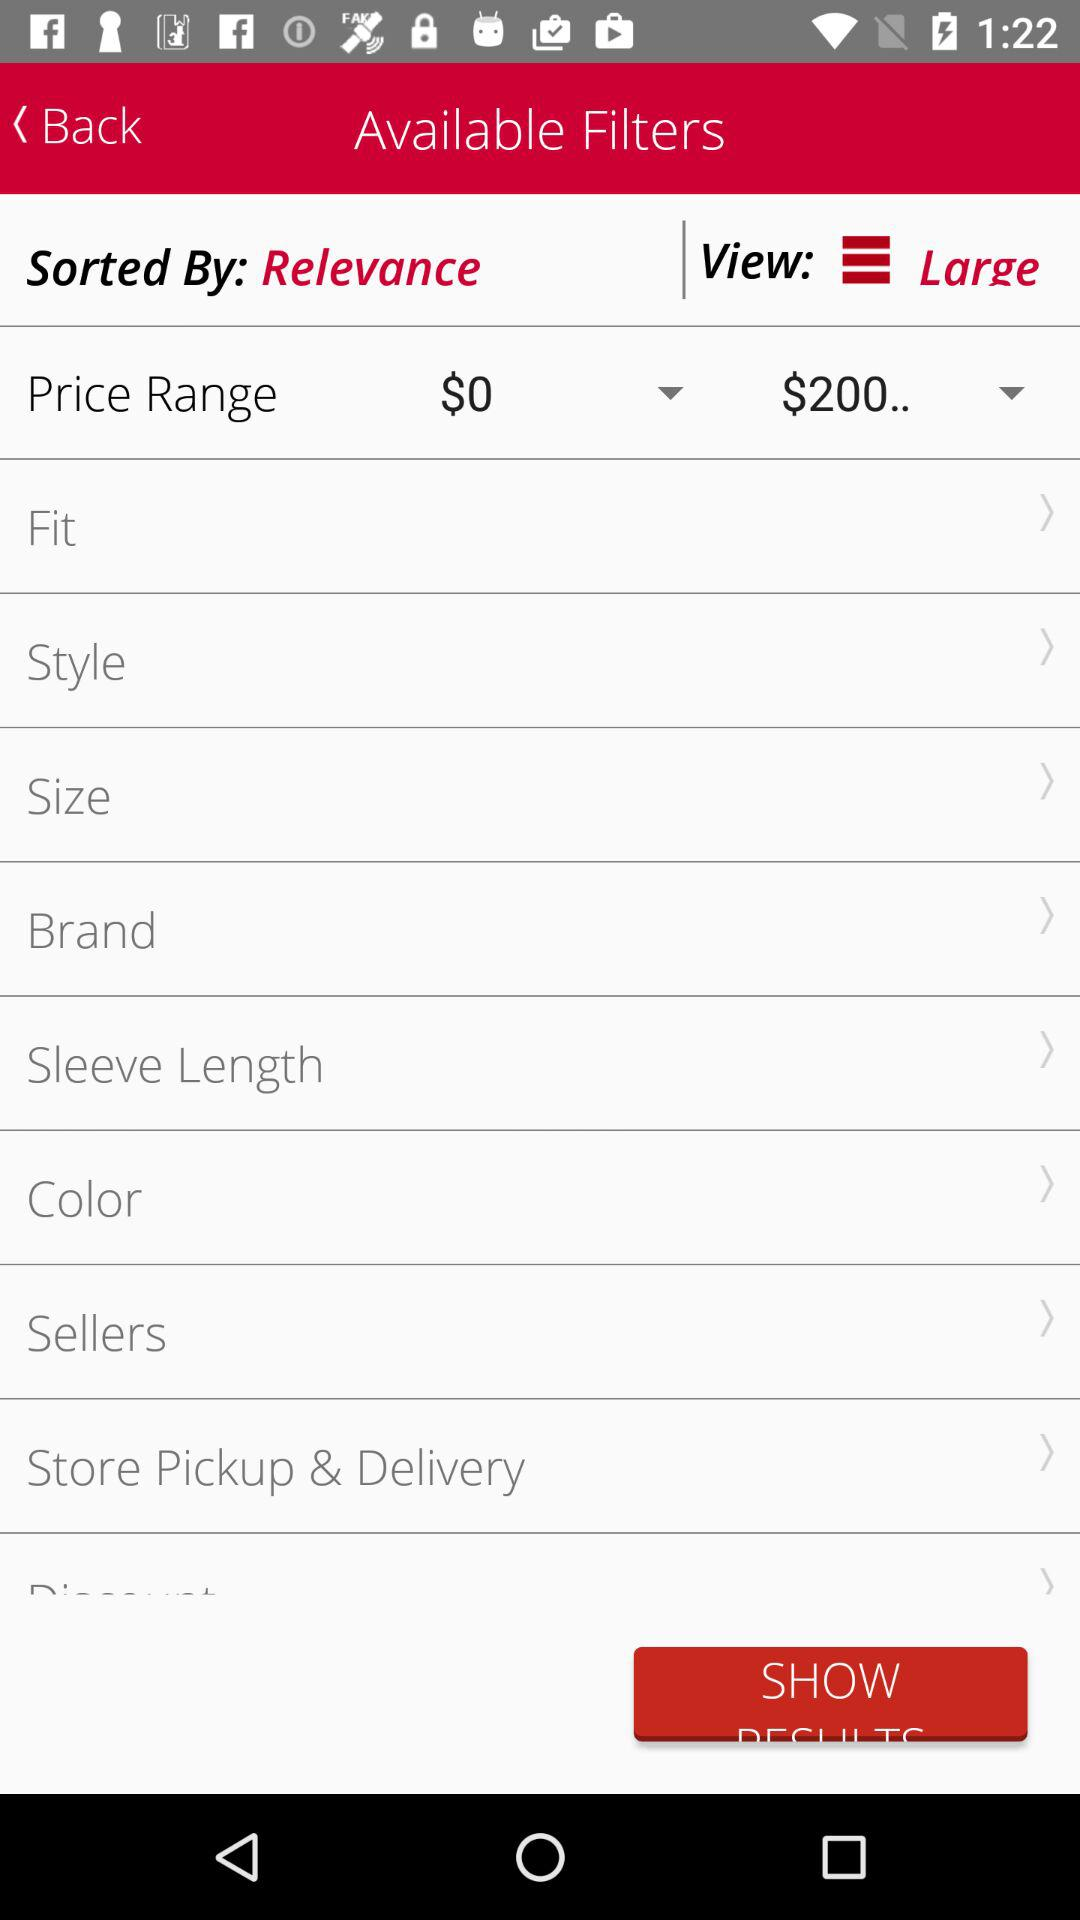What is the selected price range? The selected price ranges from $0 to "$200..". 